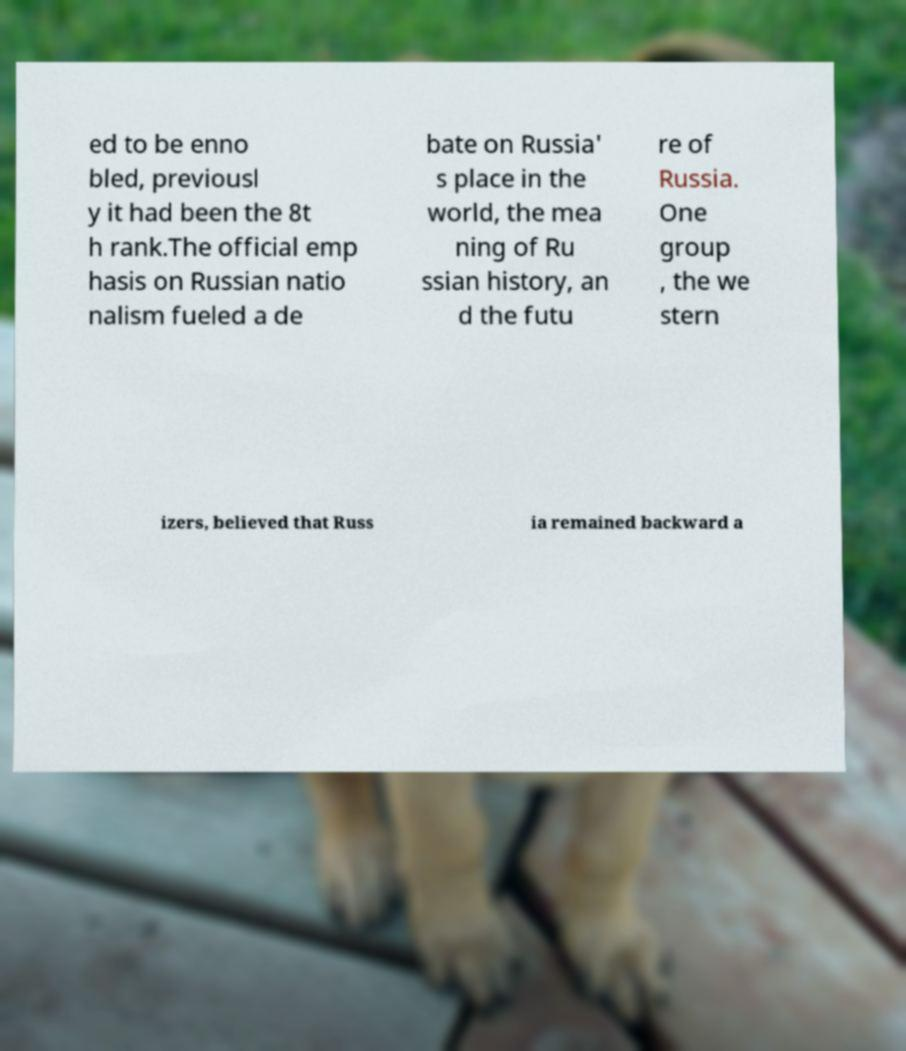There's text embedded in this image that I need extracted. Can you transcribe it verbatim? ed to be enno bled, previousl y it had been the 8t h rank.The official emp hasis on Russian natio nalism fueled a de bate on Russia' s place in the world, the mea ning of Ru ssian history, an d the futu re of Russia. One group , the we stern izers, believed that Russ ia remained backward a 